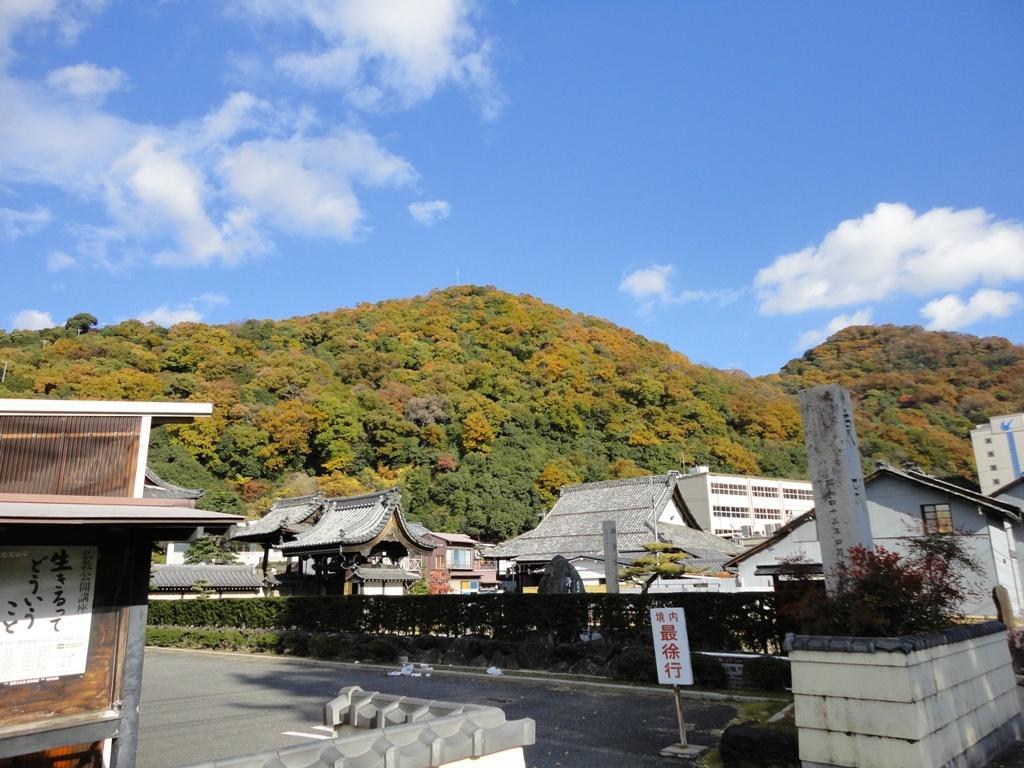Describe this image in one or two sentences. In this image, we can see trees, sheds, buildings, plants and we can see a board on the road. At the top, there are clouds in the sky. 